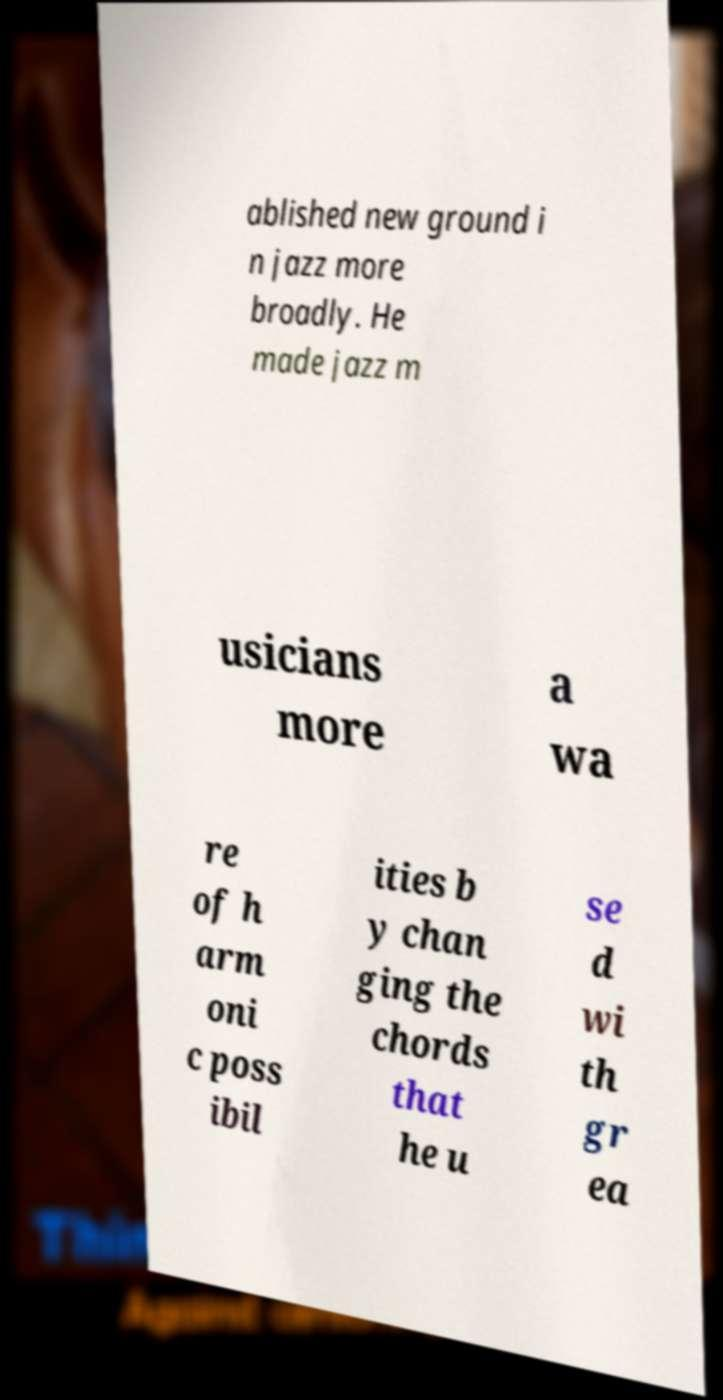For documentation purposes, I need the text within this image transcribed. Could you provide that? ablished new ground i n jazz more broadly. He made jazz m usicians more a wa re of h arm oni c poss ibil ities b y chan ging the chords that he u se d wi th gr ea 